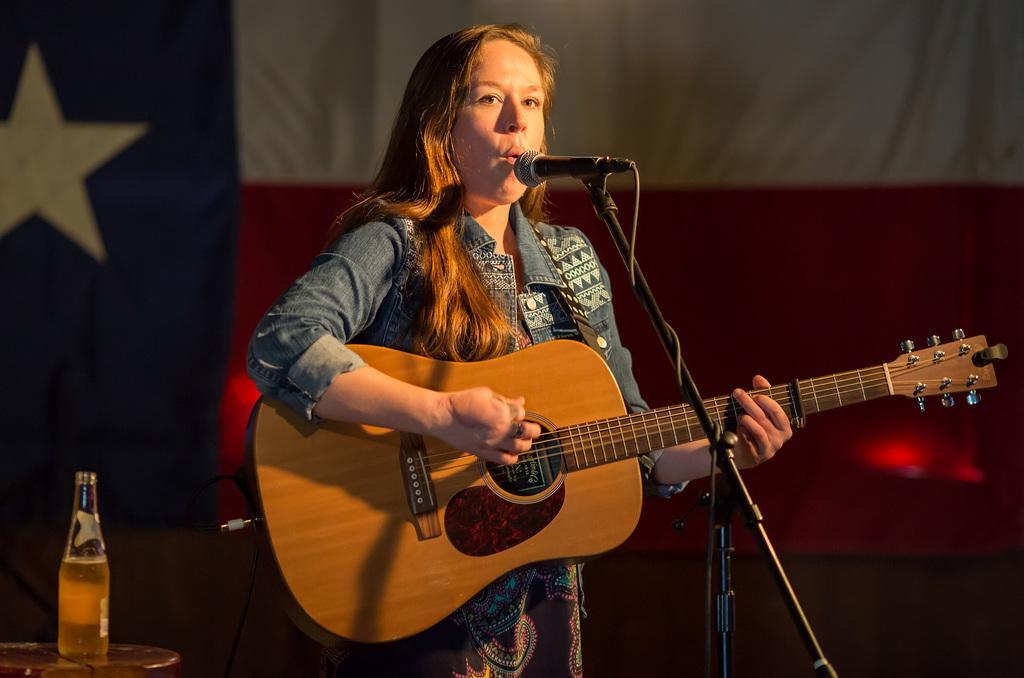Describe this image in one or two sentences. In this image there is a person wearing clothes and playing a guitar. This person is standing in front of the mic. There is a table in the bottom left of the image contains a bottle. 